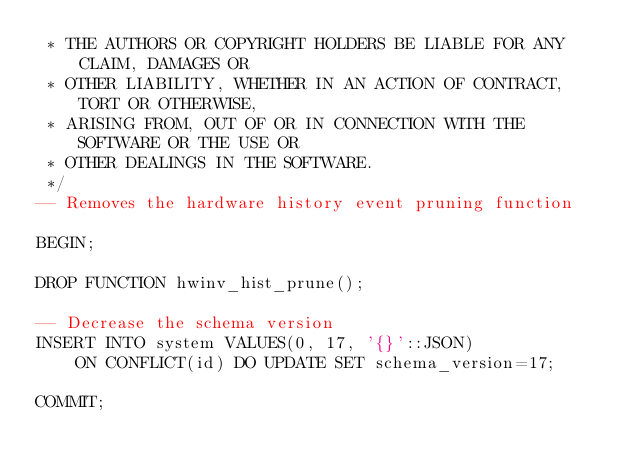Convert code to text. <code><loc_0><loc_0><loc_500><loc_500><_SQL_> * THE AUTHORS OR COPYRIGHT HOLDERS BE LIABLE FOR ANY CLAIM, DAMAGES OR
 * OTHER LIABILITY, WHETHER IN AN ACTION OF CONTRACT, TORT OR OTHERWISE,
 * ARISING FROM, OUT OF OR IN CONNECTION WITH THE SOFTWARE OR THE USE OR
 * OTHER DEALINGS IN THE SOFTWARE.
 */
-- Removes the hardware history event pruning function

BEGIN;

DROP FUNCTION hwinv_hist_prune();

-- Decrease the schema version
INSERT INTO system VALUES(0, 17, '{}'::JSON)
    ON CONFLICT(id) DO UPDATE SET schema_version=17;

COMMIT;</code> 